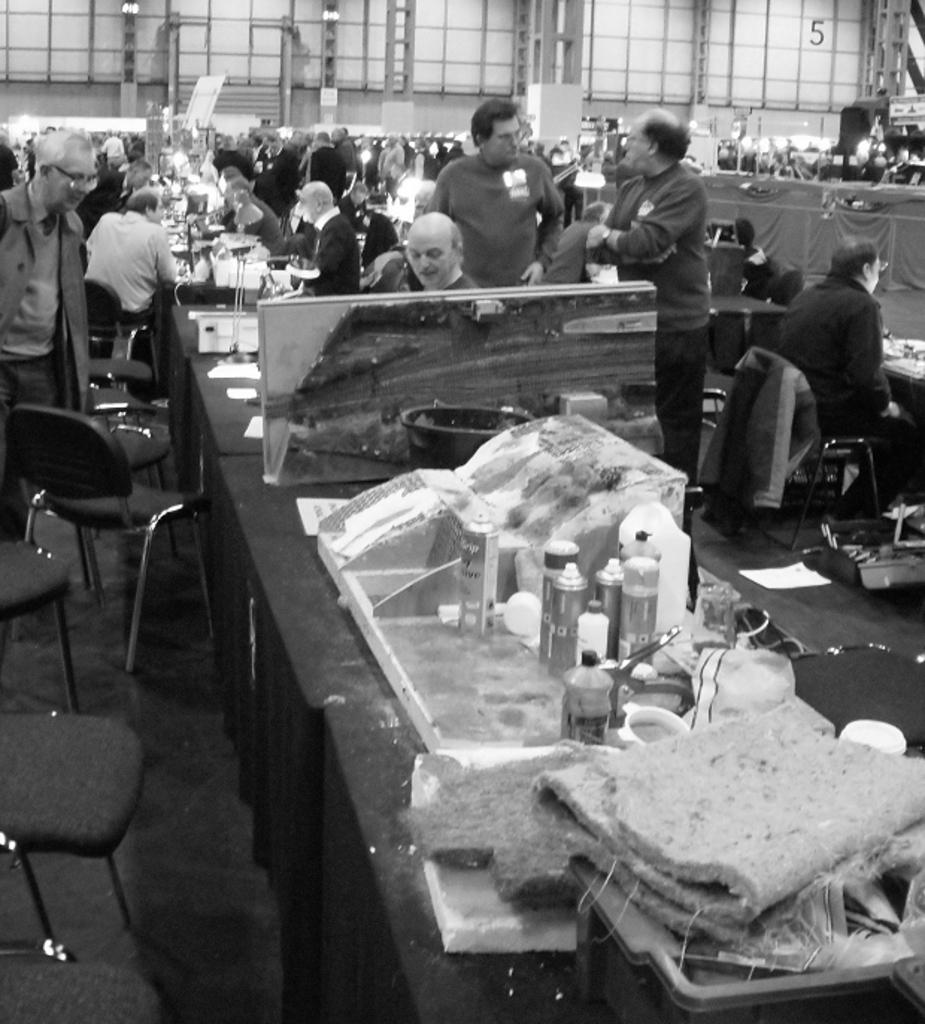Describe this image in one or two sentences. It is a black and white image. In this image we can see the people standing and there are a few people sitting on the chairs which are on the floor. We can also see the tables and on the tables we can see the bottles, mats and also some other objects. In the background we can see the wall and also the rods. 